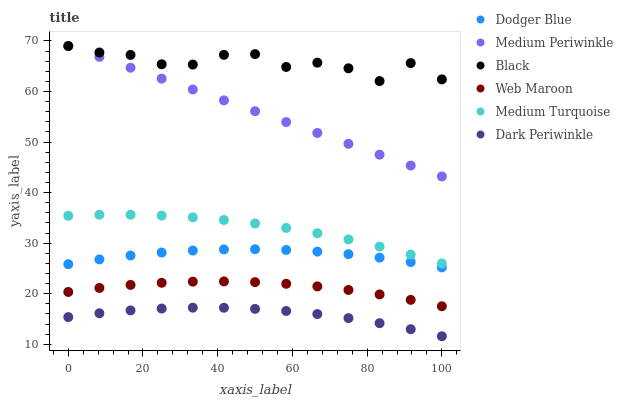Does Dark Periwinkle have the minimum area under the curve?
Answer yes or no. Yes. Does Black have the maximum area under the curve?
Answer yes or no. Yes. Does Web Maroon have the minimum area under the curve?
Answer yes or no. No. Does Web Maroon have the maximum area under the curve?
Answer yes or no. No. Is Medium Periwinkle the smoothest?
Answer yes or no. Yes. Is Black the roughest?
Answer yes or no. Yes. Is Web Maroon the smoothest?
Answer yes or no. No. Is Web Maroon the roughest?
Answer yes or no. No. Does Dark Periwinkle have the lowest value?
Answer yes or no. Yes. Does Web Maroon have the lowest value?
Answer yes or no. No. Does Black have the highest value?
Answer yes or no. Yes. Does Web Maroon have the highest value?
Answer yes or no. No. Is Dark Periwinkle less than Black?
Answer yes or no. Yes. Is Dodger Blue greater than Web Maroon?
Answer yes or no. Yes. Does Black intersect Medium Periwinkle?
Answer yes or no. Yes. Is Black less than Medium Periwinkle?
Answer yes or no. No. Is Black greater than Medium Periwinkle?
Answer yes or no. No. Does Dark Periwinkle intersect Black?
Answer yes or no. No. 